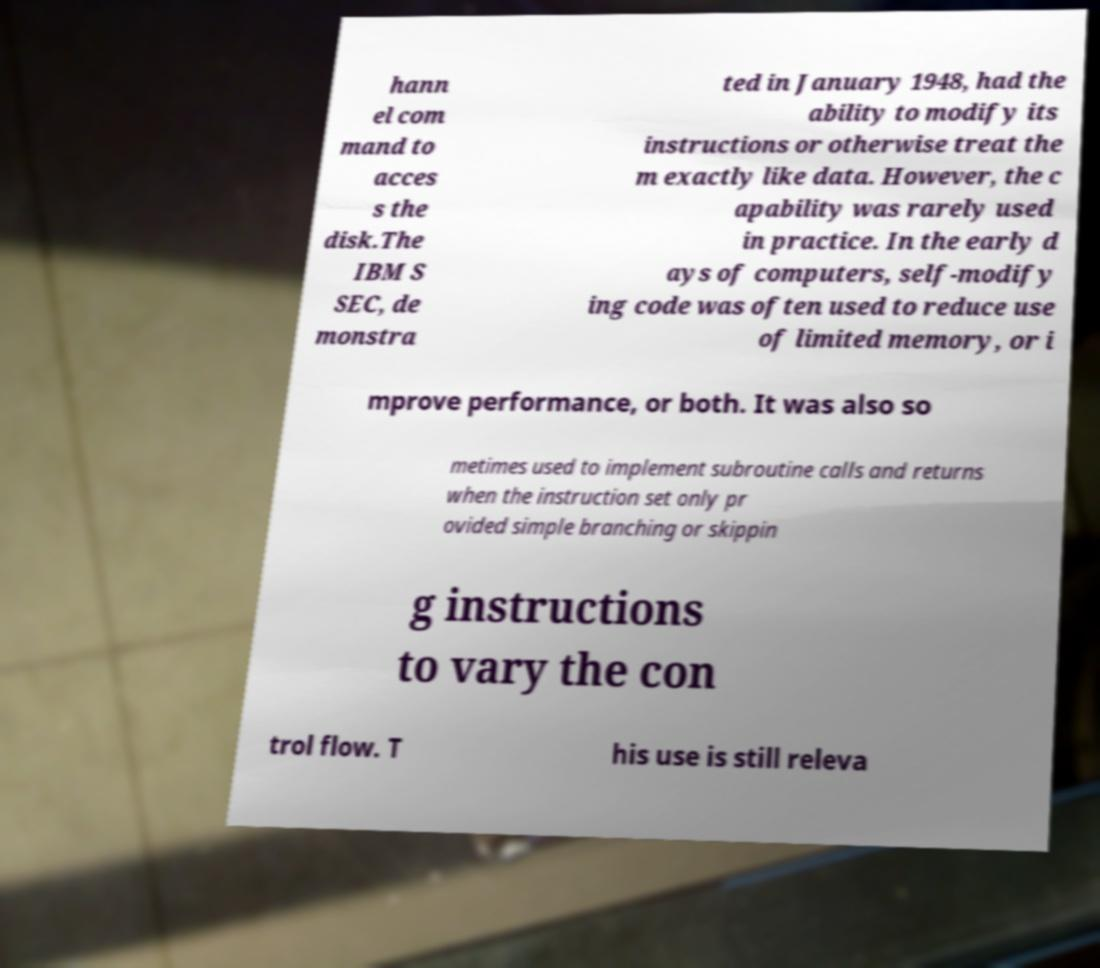Could you assist in decoding the text presented in this image and type it out clearly? hann el com mand to acces s the disk.The IBM S SEC, de monstra ted in January 1948, had the ability to modify its instructions or otherwise treat the m exactly like data. However, the c apability was rarely used in practice. In the early d ays of computers, self-modify ing code was often used to reduce use of limited memory, or i mprove performance, or both. It was also so metimes used to implement subroutine calls and returns when the instruction set only pr ovided simple branching or skippin g instructions to vary the con trol flow. T his use is still releva 